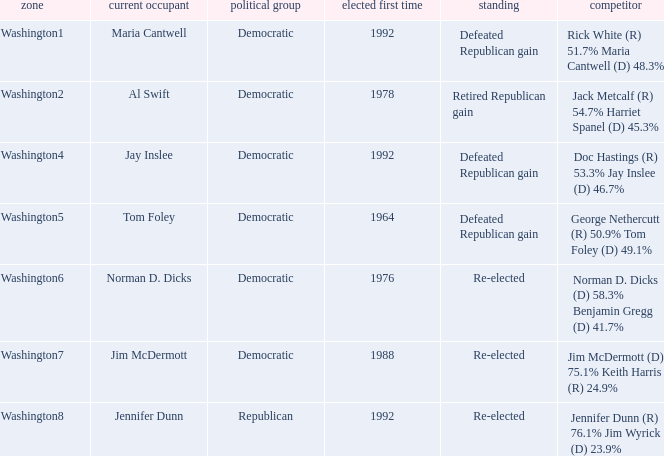Parse the full table. {'header': ['zone', 'current occupant', 'political group', 'elected first time', 'standing', 'competitor'], 'rows': [['Washington1', 'Maria Cantwell', 'Democratic', '1992', 'Defeated Republican gain', 'Rick White (R) 51.7% Maria Cantwell (D) 48.3%'], ['Washington2', 'Al Swift', 'Democratic', '1978', 'Retired Republican gain', 'Jack Metcalf (R) 54.7% Harriet Spanel (D) 45.3%'], ['Washington4', 'Jay Inslee', 'Democratic', '1992', 'Defeated Republican gain', 'Doc Hastings (R) 53.3% Jay Inslee (D) 46.7%'], ['Washington5', 'Tom Foley', 'Democratic', '1964', 'Defeated Republican gain', 'George Nethercutt (R) 50.9% Tom Foley (D) 49.1%'], ['Washington6', 'Norman D. Dicks', 'Democratic', '1976', 'Re-elected', 'Norman D. Dicks (D) 58.3% Benjamin Gregg (D) 41.7%'], ['Washington7', 'Jim McDermott', 'Democratic', '1988', 'Re-elected', 'Jim McDermott (D) 75.1% Keith Harris (R) 24.9%'], ['Washington8', 'Jennifer Dunn', 'Republican', '1992', 'Re-elected', 'Jennifer Dunn (R) 76.1% Jim Wyrick (D) 23.9%']]} What year was incumbent jim mcdermott first elected? 1988.0. 